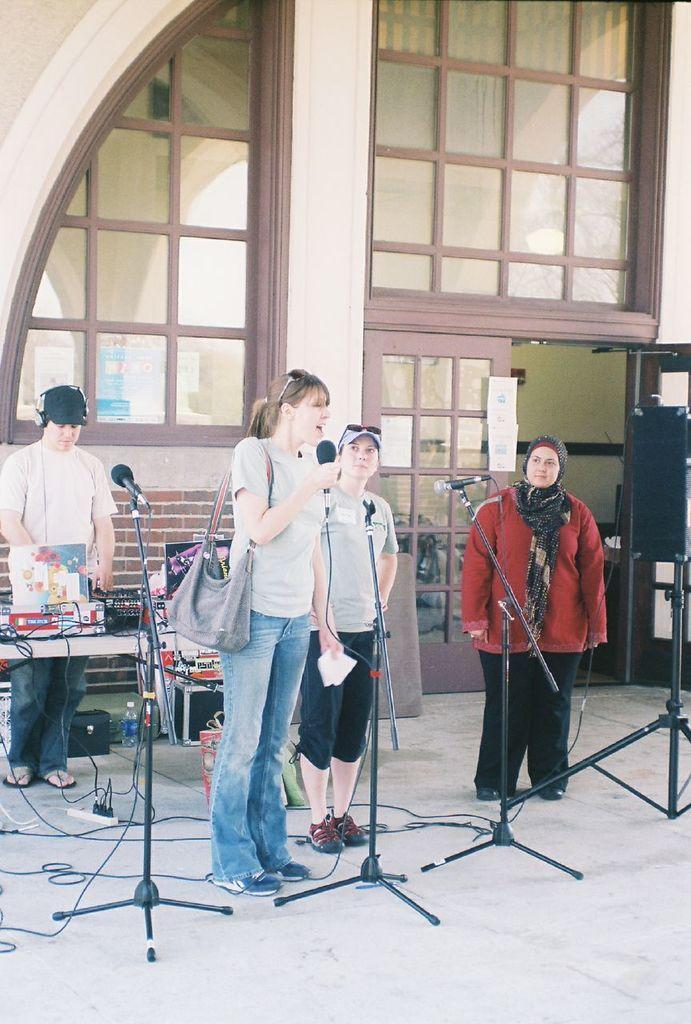Can you describe this image briefly? In this image there are group of persons who are standing on the floor in front of them there are microphones and at the background there is a building 